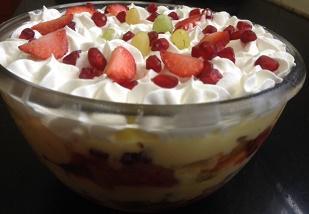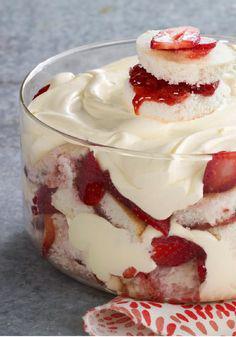The first image is the image on the left, the second image is the image on the right. Examine the images to the left and right. Is the description "One of the images contains exactly two dessert filled containers." accurate? Answer yes or no. No. 